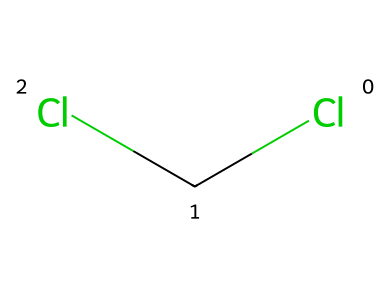How many chlorine atoms are present in dichloromethane? The SMILES representation shows "Cl" repeating twice, indicating two chlorine atoms.
Answer: 2 What type of bonding is present in the dichloromethane structure? The presence of "C" bonded to "Cl" indicates covalent bonds. Each "C-Cl" connection represents a covalent bond.
Answer: covalent bonds What is the molecular formula of dichloromethane? In the chemical structure, there is one carbon atom and two chlorine atoms. As no hydrogen atoms are explicitly shown in the SMILES, we infer the full molecular formula is CH2Cl2.
Answer: CH2Cl2 How many total atoms are there in the dichloromethane molecule? There is one carbon atom (C), two chlorine atoms (Cl), and inferred two hydrogen atoms (H), totaling five atoms.
Answer: 5 What role does dichloromethane play in plastic production? Dichloromethane is often used as a solvent in the production process, aiding in the dissolution of certain polymers.
Answer: solvent What type of solvent is dichloromethane considered? Given its properties, dichloromethane is categorized as a volatile organic solvent due to its ability to evaporate quickly at room temperature.
Answer: volatile organic solvent 